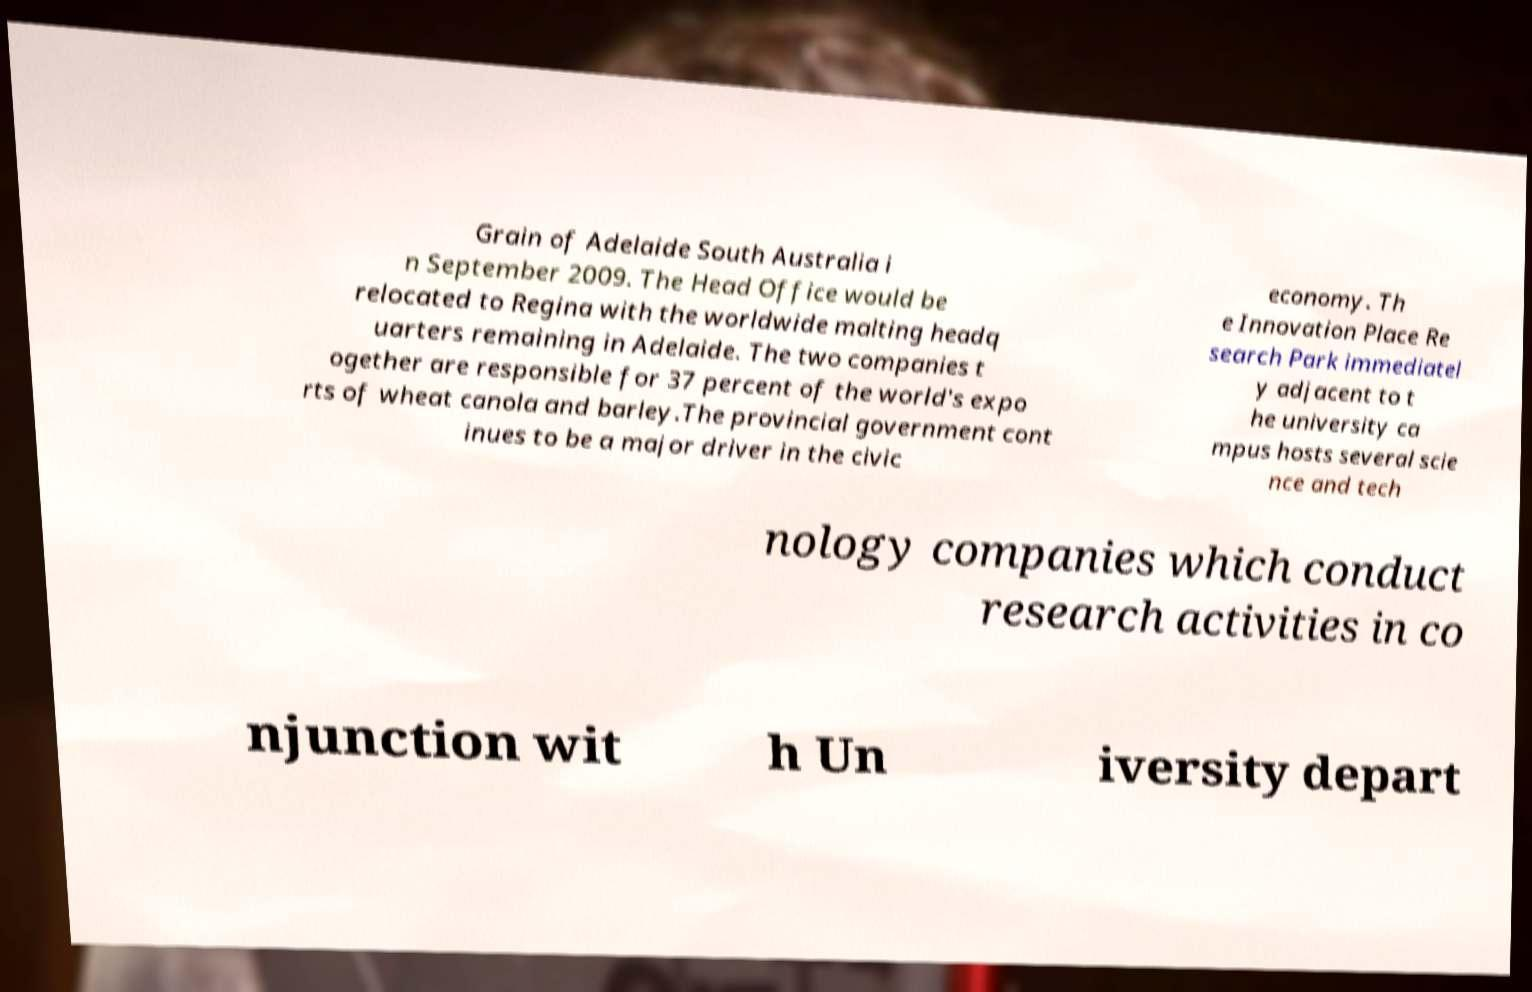There's text embedded in this image that I need extracted. Can you transcribe it verbatim? Grain of Adelaide South Australia i n September 2009. The Head Office would be relocated to Regina with the worldwide malting headq uarters remaining in Adelaide. The two companies t ogether are responsible for 37 percent of the world's expo rts of wheat canola and barley.The provincial government cont inues to be a major driver in the civic economy. Th e Innovation Place Re search Park immediatel y adjacent to t he university ca mpus hosts several scie nce and tech nology companies which conduct research activities in co njunction wit h Un iversity depart 